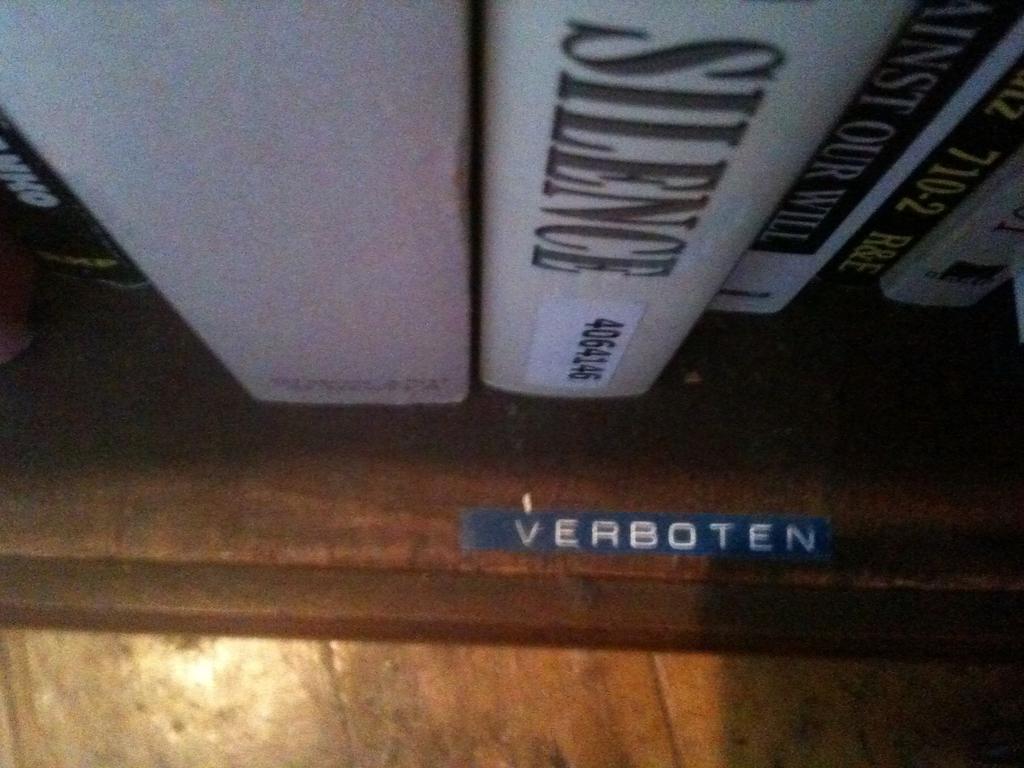What does the label on the shelf say?
Your response must be concise. Verboten. What number is on the label of the book titled silence?
Provide a short and direct response. 4064146. 